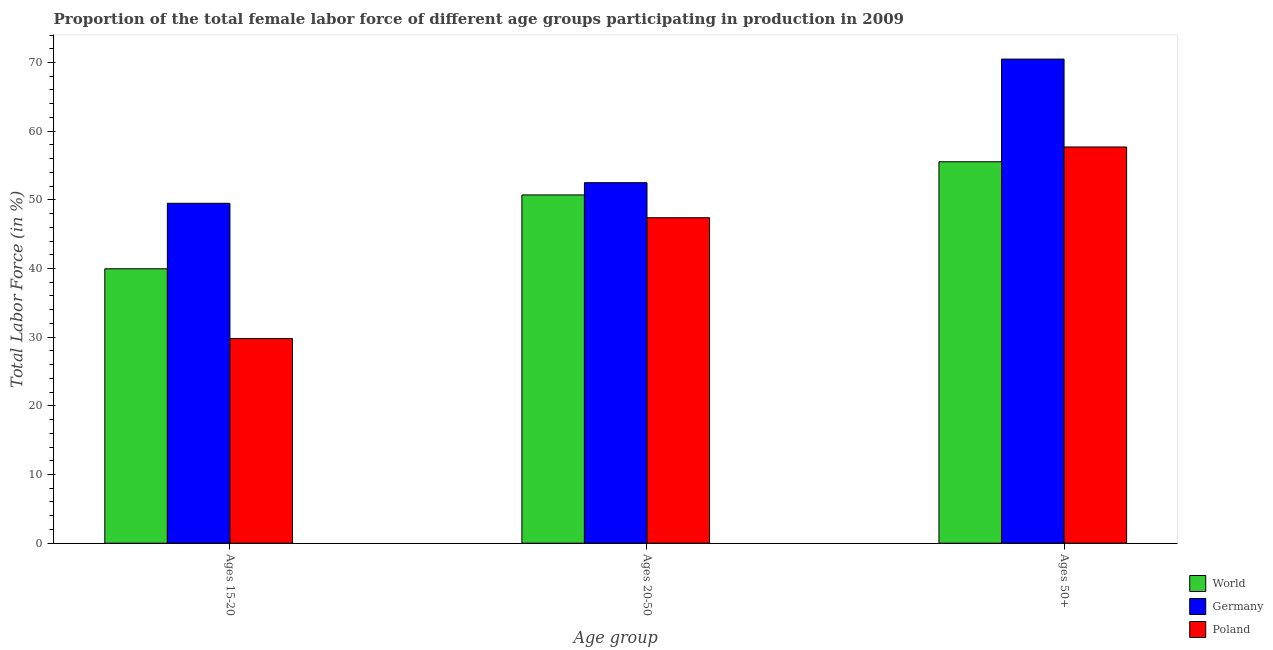Are the number of bars per tick equal to the number of legend labels?
Offer a very short reply. Yes. How many bars are there on the 1st tick from the right?
Provide a short and direct response. 3. What is the label of the 2nd group of bars from the left?
Provide a short and direct response. Ages 20-50. What is the percentage of female labor force within the age group 15-20 in Germany?
Make the answer very short. 49.5. Across all countries, what is the maximum percentage of female labor force above age 50?
Offer a very short reply. 70.5. Across all countries, what is the minimum percentage of female labor force within the age group 20-50?
Your response must be concise. 47.4. In which country was the percentage of female labor force within the age group 20-50 minimum?
Your answer should be compact. Poland. What is the total percentage of female labor force above age 50 in the graph?
Provide a short and direct response. 183.75. What is the difference between the percentage of female labor force above age 50 in Germany and that in World?
Offer a terse response. 14.95. What is the difference between the percentage of female labor force within the age group 15-20 in Poland and the percentage of female labor force within the age group 20-50 in Germany?
Keep it short and to the point. -22.7. What is the average percentage of female labor force within the age group 20-50 per country?
Give a very brief answer. 50.21. What is the difference between the percentage of female labor force within the age group 20-50 and percentage of female labor force above age 50 in Poland?
Make the answer very short. -10.3. In how many countries, is the percentage of female labor force within the age group 20-50 greater than 6 %?
Offer a very short reply. 3. What is the ratio of the percentage of female labor force within the age group 20-50 in Germany to that in World?
Make the answer very short. 1.04. Is the percentage of female labor force within the age group 15-20 in Germany less than that in Poland?
Make the answer very short. No. What is the difference between the highest and the second highest percentage of female labor force within the age group 15-20?
Make the answer very short. 9.54. What is the difference between the highest and the lowest percentage of female labor force within the age group 20-50?
Make the answer very short. 5.1. How many bars are there?
Provide a succinct answer. 9. Are all the bars in the graph horizontal?
Make the answer very short. No. Are the values on the major ticks of Y-axis written in scientific E-notation?
Your response must be concise. No. Does the graph contain grids?
Offer a very short reply. No. How many legend labels are there?
Your response must be concise. 3. What is the title of the graph?
Provide a succinct answer. Proportion of the total female labor force of different age groups participating in production in 2009. Does "Antigua and Barbuda" appear as one of the legend labels in the graph?
Ensure brevity in your answer.  No. What is the label or title of the X-axis?
Keep it short and to the point. Age group. What is the label or title of the Y-axis?
Make the answer very short. Total Labor Force (in %). What is the Total Labor Force (in %) in World in Ages 15-20?
Keep it short and to the point. 39.96. What is the Total Labor Force (in %) of Germany in Ages 15-20?
Provide a succinct answer. 49.5. What is the Total Labor Force (in %) of Poland in Ages 15-20?
Keep it short and to the point. 29.8. What is the Total Labor Force (in %) of World in Ages 20-50?
Give a very brief answer. 50.72. What is the Total Labor Force (in %) of Germany in Ages 20-50?
Provide a succinct answer. 52.5. What is the Total Labor Force (in %) in Poland in Ages 20-50?
Provide a succinct answer. 47.4. What is the Total Labor Force (in %) of World in Ages 50+?
Your answer should be compact. 55.55. What is the Total Labor Force (in %) of Germany in Ages 50+?
Your answer should be very brief. 70.5. What is the Total Labor Force (in %) of Poland in Ages 50+?
Your response must be concise. 57.7. Across all Age group, what is the maximum Total Labor Force (in %) in World?
Make the answer very short. 55.55. Across all Age group, what is the maximum Total Labor Force (in %) of Germany?
Provide a short and direct response. 70.5. Across all Age group, what is the maximum Total Labor Force (in %) of Poland?
Provide a short and direct response. 57.7. Across all Age group, what is the minimum Total Labor Force (in %) of World?
Your answer should be compact. 39.96. Across all Age group, what is the minimum Total Labor Force (in %) in Germany?
Your answer should be compact. 49.5. Across all Age group, what is the minimum Total Labor Force (in %) in Poland?
Give a very brief answer. 29.8. What is the total Total Labor Force (in %) in World in the graph?
Provide a short and direct response. 146.22. What is the total Total Labor Force (in %) in Germany in the graph?
Your answer should be very brief. 172.5. What is the total Total Labor Force (in %) of Poland in the graph?
Offer a terse response. 134.9. What is the difference between the Total Labor Force (in %) in World in Ages 15-20 and that in Ages 20-50?
Provide a short and direct response. -10.75. What is the difference between the Total Labor Force (in %) of Poland in Ages 15-20 and that in Ages 20-50?
Offer a very short reply. -17.6. What is the difference between the Total Labor Force (in %) of World in Ages 15-20 and that in Ages 50+?
Your answer should be compact. -15.59. What is the difference between the Total Labor Force (in %) of Germany in Ages 15-20 and that in Ages 50+?
Your answer should be very brief. -21. What is the difference between the Total Labor Force (in %) of Poland in Ages 15-20 and that in Ages 50+?
Your response must be concise. -27.9. What is the difference between the Total Labor Force (in %) in World in Ages 20-50 and that in Ages 50+?
Make the answer very short. -4.83. What is the difference between the Total Labor Force (in %) in Germany in Ages 20-50 and that in Ages 50+?
Provide a succinct answer. -18. What is the difference between the Total Labor Force (in %) in Poland in Ages 20-50 and that in Ages 50+?
Keep it short and to the point. -10.3. What is the difference between the Total Labor Force (in %) of World in Ages 15-20 and the Total Labor Force (in %) of Germany in Ages 20-50?
Your response must be concise. -12.54. What is the difference between the Total Labor Force (in %) of World in Ages 15-20 and the Total Labor Force (in %) of Poland in Ages 20-50?
Your answer should be compact. -7.44. What is the difference between the Total Labor Force (in %) of Germany in Ages 15-20 and the Total Labor Force (in %) of Poland in Ages 20-50?
Your answer should be compact. 2.1. What is the difference between the Total Labor Force (in %) of World in Ages 15-20 and the Total Labor Force (in %) of Germany in Ages 50+?
Give a very brief answer. -30.54. What is the difference between the Total Labor Force (in %) in World in Ages 15-20 and the Total Labor Force (in %) in Poland in Ages 50+?
Give a very brief answer. -17.74. What is the difference between the Total Labor Force (in %) of World in Ages 20-50 and the Total Labor Force (in %) of Germany in Ages 50+?
Provide a short and direct response. -19.78. What is the difference between the Total Labor Force (in %) in World in Ages 20-50 and the Total Labor Force (in %) in Poland in Ages 50+?
Ensure brevity in your answer.  -6.98. What is the difference between the Total Labor Force (in %) of Germany in Ages 20-50 and the Total Labor Force (in %) of Poland in Ages 50+?
Your answer should be very brief. -5.2. What is the average Total Labor Force (in %) of World per Age group?
Offer a terse response. 48.74. What is the average Total Labor Force (in %) in Germany per Age group?
Make the answer very short. 57.5. What is the average Total Labor Force (in %) of Poland per Age group?
Keep it short and to the point. 44.97. What is the difference between the Total Labor Force (in %) in World and Total Labor Force (in %) in Germany in Ages 15-20?
Your answer should be compact. -9.54. What is the difference between the Total Labor Force (in %) in World and Total Labor Force (in %) in Poland in Ages 15-20?
Provide a short and direct response. 10.16. What is the difference between the Total Labor Force (in %) of Germany and Total Labor Force (in %) of Poland in Ages 15-20?
Keep it short and to the point. 19.7. What is the difference between the Total Labor Force (in %) of World and Total Labor Force (in %) of Germany in Ages 20-50?
Give a very brief answer. -1.78. What is the difference between the Total Labor Force (in %) of World and Total Labor Force (in %) of Poland in Ages 20-50?
Offer a very short reply. 3.32. What is the difference between the Total Labor Force (in %) in Germany and Total Labor Force (in %) in Poland in Ages 20-50?
Your answer should be compact. 5.1. What is the difference between the Total Labor Force (in %) of World and Total Labor Force (in %) of Germany in Ages 50+?
Ensure brevity in your answer.  -14.95. What is the difference between the Total Labor Force (in %) of World and Total Labor Force (in %) of Poland in Ages 50+?
Your response must be concise. -2.15. What is the ratio of the Total Labor Force (in %) in World in Ages 15-20 to that in Ages 20-50?
Offer a very short reply. 0.79. What is the ratio of the Total Labor Force (in %) of Germany in Ages 15-20 to that in Ages 20-50?
Keep it short and to the point. 0.94. What is the ratio of the Total Labor Force (in %) of Poland in Ages 15-20 to that in Ages 20-50?
Ensure brevity in your answer.  0.63. What is the ratio of the Total Labor Force (in %) in World in Ages 15-20 to that in Ages 50+?
Make the answer very short. 0.72. What is the ratio of the Total Labor Force (in %) in Germany in Ages 15-20 to that in Ages 50+?
Give a very brief answer. 0.7. What is the ratio of the Total Labor Force (in %) of Poland in Ages 15-20 to that in Ages 50+?
Make the answer very short. 0.52. What is the ratio of the Total Labor Force (in %) of Germany in Ages 20-50 to that in Ages 50+?
Keep it short and to the point. 0.74. What is the ratio of the Total Labor Force (in %) of Poland in Ages 20-50 to that in Ages 50+?
Offer a terse response. 0.82. What is the difference between the highest and the second highest Total Labor Force (in %) of World?
Provide a short and direct response. 4.83. What is the difference between the highest and the lowest Total Labor Force (in %) of World?
Ensure brevity in your answer.  15.59. What is the difference between the highest and the lowest Total Labor Force (in %) in Poland?
Keep it short and to the point. 27.9. 